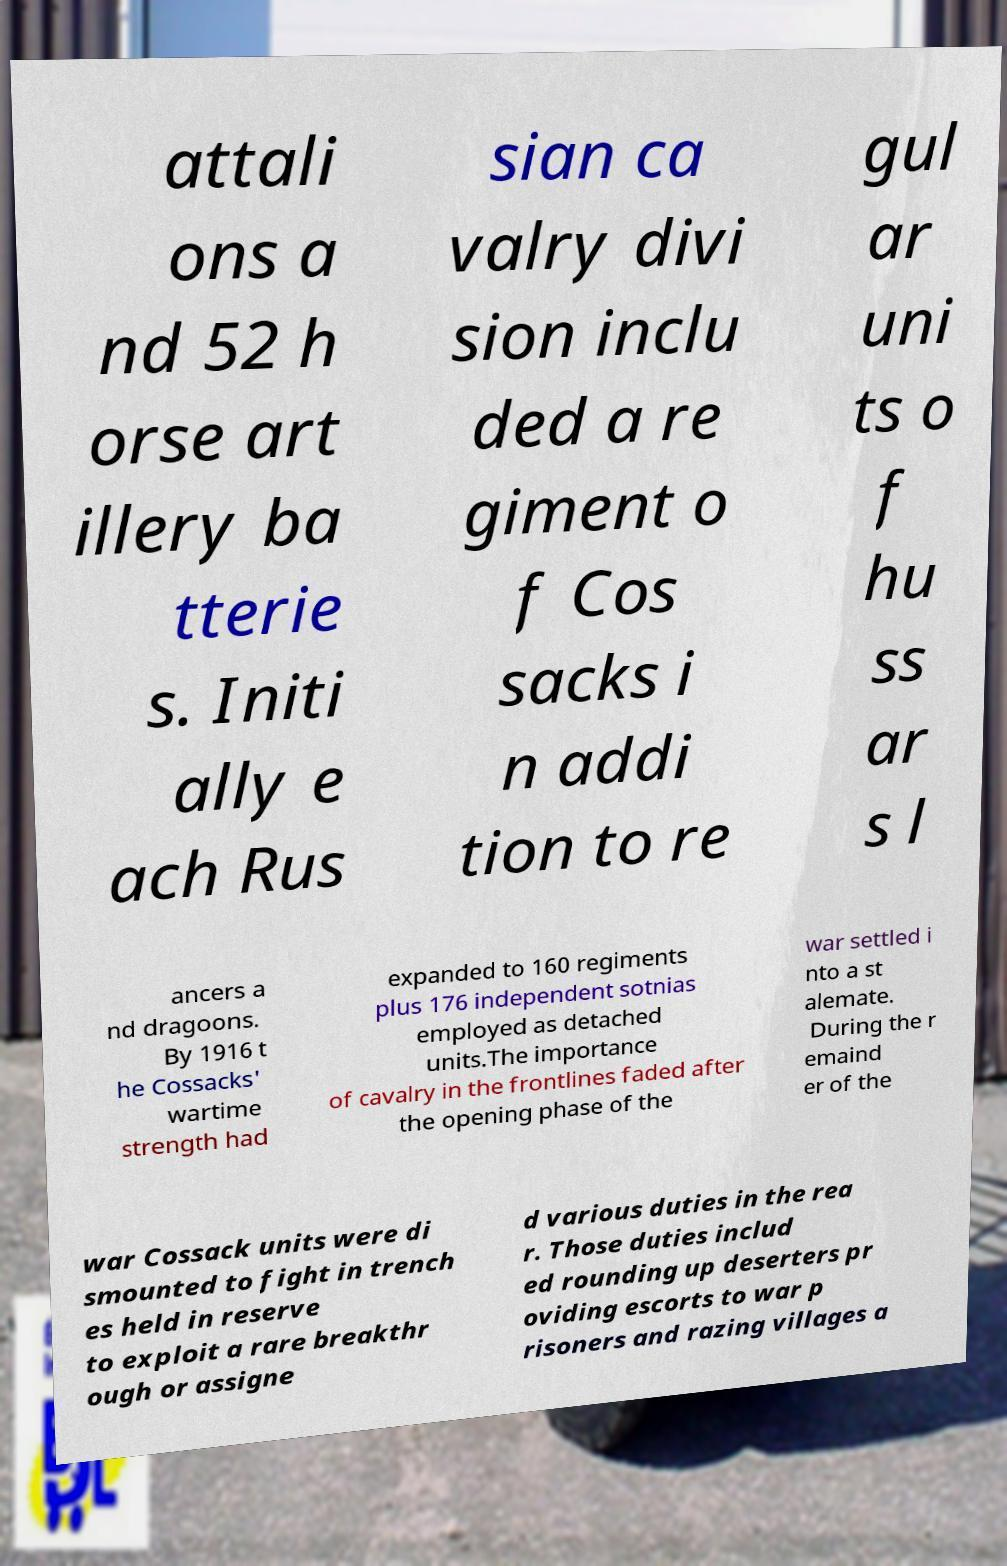Could you assist in decoding the text presented in this image and type it out clearly? attali ons a nd 52 h orse art illery ba tterie s. Initi ally e ach Rus sian ca valry divi sion inclu ded a re giment o f Cos sacks i n addi tion to re gul ar uni ts o f hu ss ar s l ancers a nd dragoons. By 1916 t he Cossacks' wartime strength had expanded to 160 regiments plus 176 independent sotnias employed as detached units.The importance of cavalry in the frontlines faded after the opening phase of the war settled i nto a st alemate. During the r emaind er of the war Cossack units were di smounted to fight in trench es held in reserve to exploit a rare breakthr ough or assigne d various duties in the rea r. Those duties includ ed rounding up deserters pr oviding escorts to war p risoners and razing villages a 